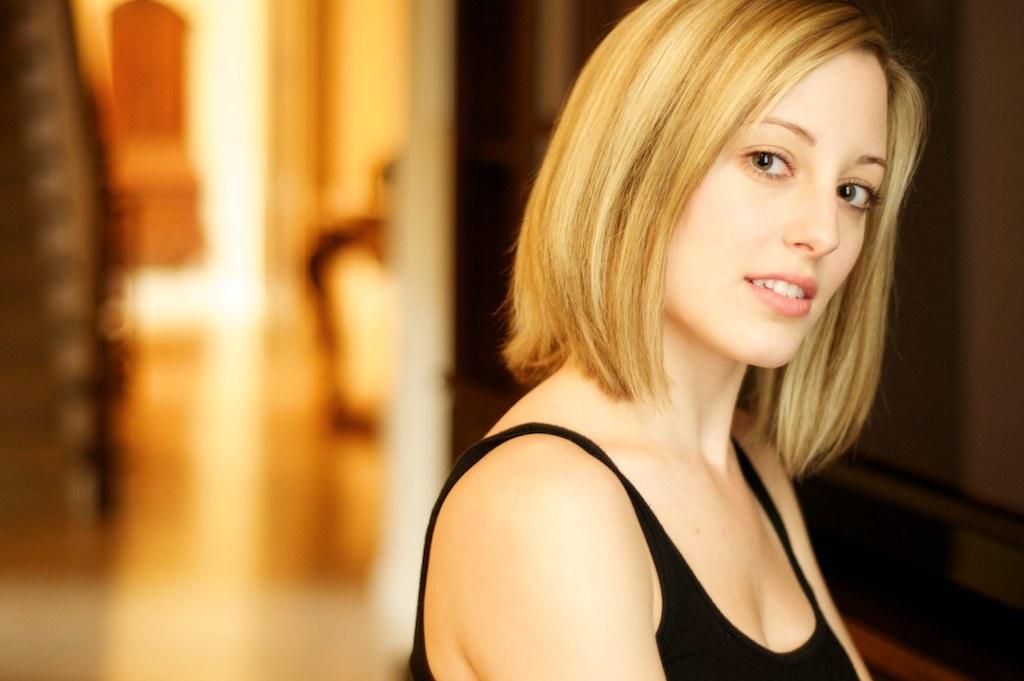What is located on the right side of the image? There is a person on the right side of the image. Can you describe the background of the image? The background of the image is blurred. What type of request is the person making in the image? There is no indication in the image that the person is making any request. 